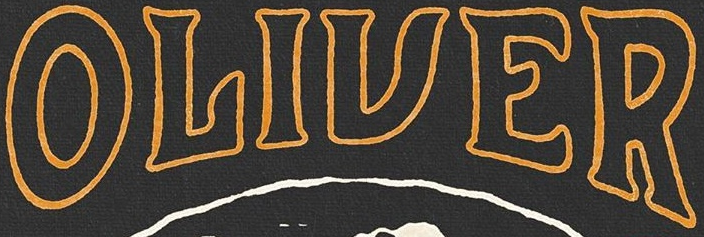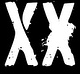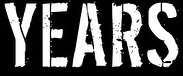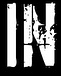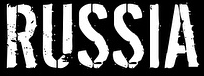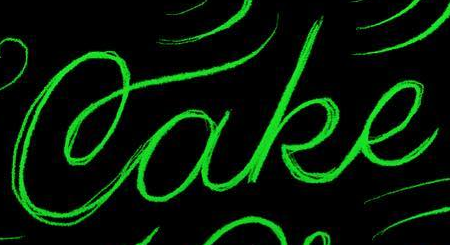Read the text content from these images in order, separated by a semicolon. OLIVER; XX; YEARS; IN; RUSSIA; Cake 